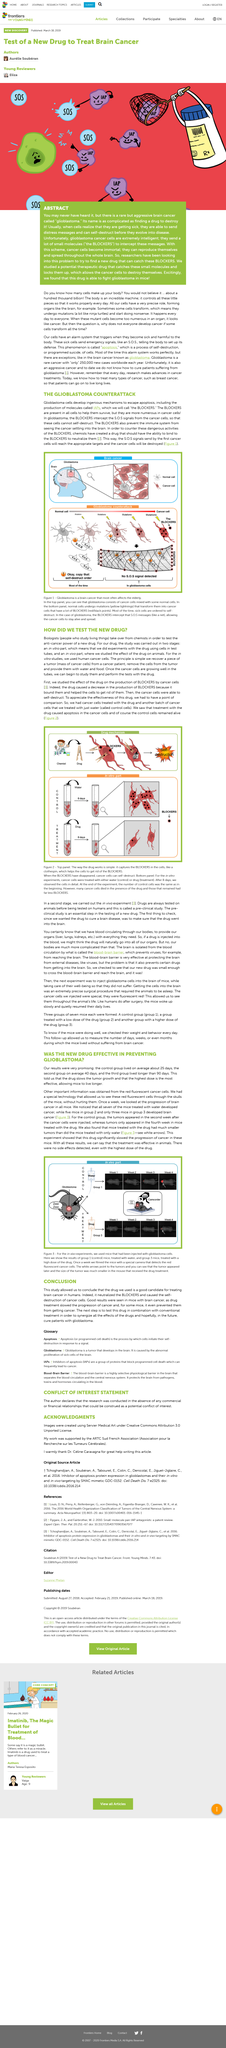Draw attention to some important aspects in this diagram. The results of the experiment showed that the mice treated with the drug had much smaller tumors than those treated with water. Glioblastoma mostly affects the elderly, with the disease more commonly diagnosed in individuals over the age of 65. Biologists study living organisms, including their physical and biological characteristics, behavior, and interactions with their environment. The treatment with the drug resulted in apoptosis occurring in the cells. Once a week, the scientists examine the progression of brain cancer in all mice. 